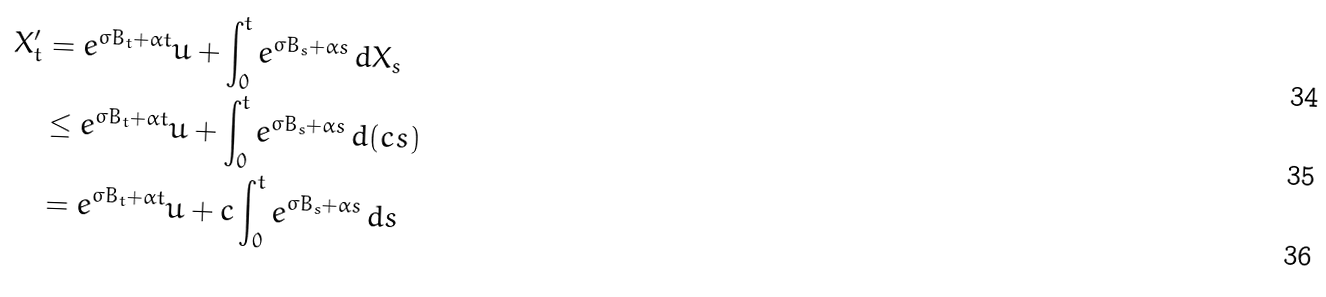Convert formula to latex. <formula><loc_0><loc_0><loc_500><loc_500>X _ { t } ^ { \prime } & = e ^ { \sigma B _ { t } + \alpha t } u + \int _ { 0 } ^ { t } e ^ { \sigma B _ { s } + \alpha s } \, d X _ { s } \\ & \leq e ^ { \sigma B _ { t } + \alpha t } u + \int _ { 0 } ^ { t } e ^ { \sigma B _ { s } + \alpha s } \, d ( c s ) \\ & = e ^ { \sigma B _ { t } + \alpha t } u + c \int _ { 0 } ^ { t } e ^ { \sigma B _ { s } + \alpha s } \, d s</formula> 